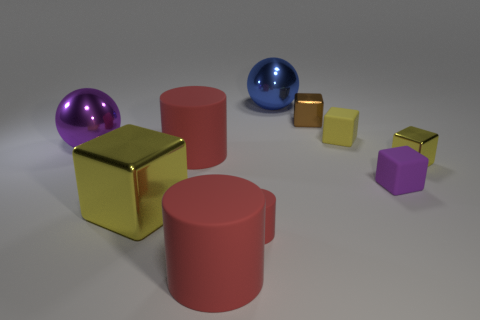What is the shape of the purple thing right of the tiny cylinder?
Your answer should be very brief. Cube. What is the color of the cylinder that is the same size as the brown shiny thing?
Your response must be concise. Red. Is the shape of the purple matte thing the same as the large purple shiny thing that is left of the tiny yellow matte thing?
Keep it short and to the point. No. There is a yellow block that is on the left side of the small rubber object that is behind the tiny metallic object that is in front of the brown block; what is its material?
Give a very brief answer. Metal. How many big objects are either yellow matte objects or rubber blocks?
Keep it short and to the point. 0. What number of other things are the same size as the blue thing?
Make the answer very short. 4. There is a metallic object right of the brown cube; is it the same shape as the brown metal thing?
Keep it short and to the point. Yes. There is another matte thing that is the same shape as the yellow rubber object; what color is it?
Ensure brevity in your answer.  Purple. Are there an equal number of big red matte things behind the big yellow metallic cube and purple shiny balls?
Your answer should be compact. Yes. What number of large metallic objects are both behind the large purple metallic sphere and left of the big blue sphere?
Provide a short and direct response. 0. 